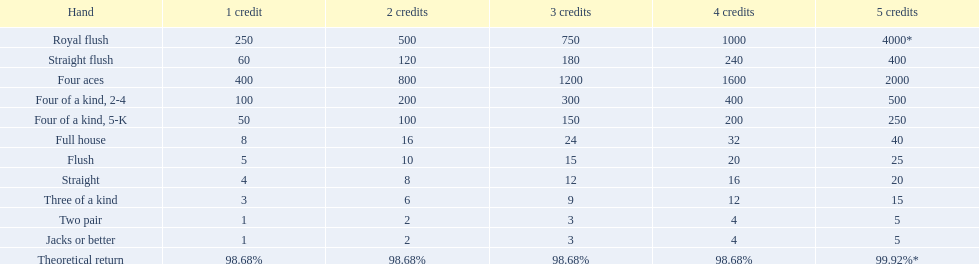What are the hands? Royal flush, Straight flush, Four aces, Four of a kind, 2-4, Four of a kind, 5-K, Full house, Flush, Straight, Three of a kind, Two pair, Jacks or better. Which hand is on the top? Royal flush. What are the top 5 best types of hand for winning? Royal flush, Straight flush, Four aces, Four of a kind, 2-4, Four of a kind, 5-K. Between those 5, which of those hands are four of a kind? Four of a kind, 2-4, Four of a kind, 5-K. Of those 2 hands, which is the best kind of four of a kind for winning? Four of a kind, 2-4. 